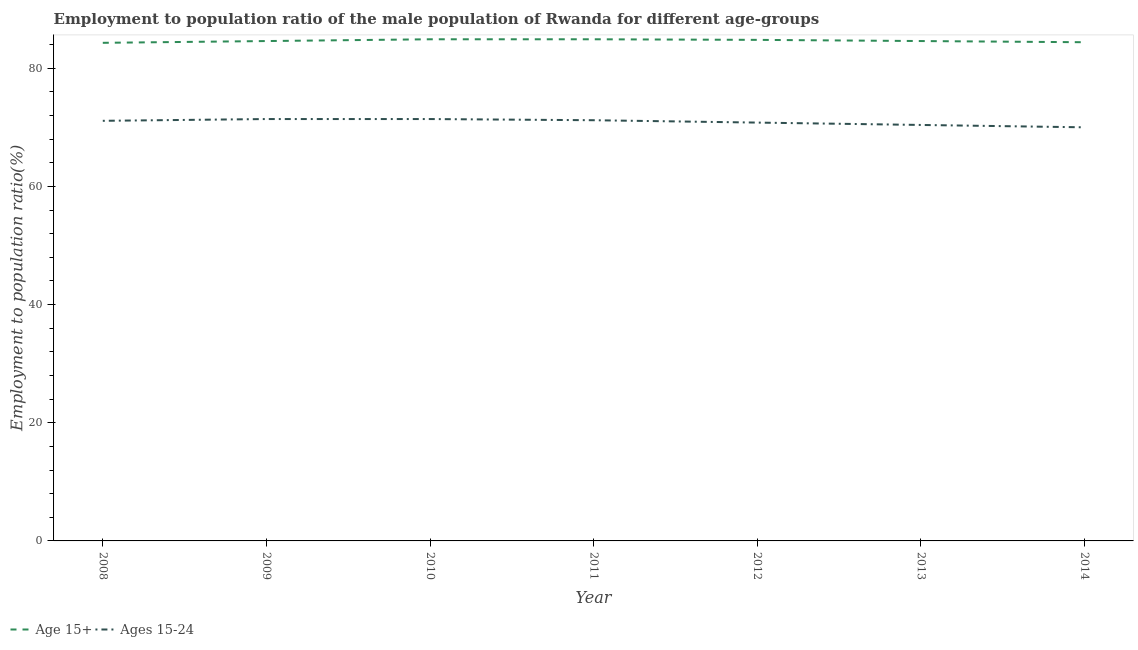Is the number of lines equal to the number of legend labels?
Provide a short and direct response. Yes. What is the employment to population ratio(age 15-24) in 2011?
Offer a terse response. 71.2. Across all years, what is the maximum employment to population ratio(age 15+)?
Make the answer very short. 84.9. Across all years, what is the minimum employment to population ratio(age 15-24)?
Ensure brevity in your answer.  70. What is the total employment to population ratio(age 15+) in the graph?
Your answer should be compact. 592.5. What is the difference between the employment to population ratio(age 15-24) in 2009 and that in 2012?
Provide a short and direct response. 0.6. What is the difference between the employment to population ratio(age 15-24) in 2011 and the employment to population ratio(age 15+) in 2010?
Provide a succinct answer. -13.7. What is the average employment to population ratio(age 15+) per year?
Offer a very short reply. 84.64. In the year 2010, what is the difference between the employment to population ratio(age 15-24) and employment to population ratio(age 15+)?
Offer a very short reply. -13.5. What is the ratio of the employment to population ratio(age 15-24) in 2010 to that in 2014?
Your answer should be very brief. 1.02. Is the difference between the employment to population ratio(age 15+) in 2012 and 2013 greater than the difference between the employment to population ratio(age 15-24) in 2012 and 2013?
Ensure brevity in your answer.  No. What is the difference between the highest and the lowest employment to population ratio(age 15-24)?
Your answer should be very brief. 1.4. Does the employment to population ratio(age 15+) monotonically increase over the years?
Give a very brief answer. No. Is the employment to population ratio(age 15+) strictly less than the employment to population ratio(age 15-24) over the years?
Provide a succinct answer. No. How many years are there in the graph?
Provide a succinct answer. 7. Does the graph contain any zero values?
Your answer should be very brief. No. Does the graph contain grids?
Your answer should be compact. No. Where does the legend appear in the graph?
Provide a succinct answer. Bottom left. What is the title of the graph?
Your response must be concise. Employment to population ratio of the male population of Rwanda for different age-groups. What is the label or title of the Y-axis?
Provide a succinct answer. Employment to population ratio(%). What is the Employment to population ratio(%) of Age 15+ in 2008?
Provide a succinct answer. 84.3. What is the Employment to population ratio(%) of Ages 15-24 in 2008?
Ensure brevity in your answer.  71.1. What is the Employment to population ratio(%) in Age 15+ in 2009?
Provide a short and direct response. 84.6. What is the Employment to population ratio(%) in Ages 15-24 in 2009?
Provide a short and direct response. 71.4. What is the Employment to population ratio(%) in Age 15+ in 2010?
Provide a short and direct response. 84.9. What is the Employment to population ratio(%) of Ages 15-24 in 2010?
Offer a very short reply. 71.4. What is the Employment to population ratio(%) in Age 15+ in 2011?
Ensure brevity in your answer.  84.9. What is the Employment to population ratio(%) in Ages 15-24 in 2011?
Give a very brief answer. 71.2. What is the Employment to population ratio(%) of Age 15+ in 2012?
Keep it short and to the point. 84.8. What is the Employment to population ratio(%) in Ages 15-24 in 2012?
Ensure brevity in your answer.  70.8. What is the Employment to population ratio(%) in Age 15+ in 2013?
Keep it short and to the point. 84.6. What is the Employment to population ratio(%) of Ages 15-24 in 2013?
Ensure brevity in your answer.  70.4. What is the Employment to population ratio(%) of Age 15+ in 2014?
Keep it short and to the point. 84.4. What is the Employment to population ratio(%) in Ages 15-24 in 2014?
Ensure brevity in your answer.  70. Across all years, what is the maximum Employment to population ratio(%) in Age 15+?
Your answer should be very brief. 84.9. Across all years, what is the maximum Employment to population ratio(%) in Ages 15-24?
Offer a very short reply. 71.4. Across all years, what is the minimum Employment to population ratio(%) of Age 15+?
Make the answer very short. 84.3. Across all years, what is the minimum Employment to population ratio(%) in Ages 15-24?
Give a very brief answer. 70. What is the total Employment to population ratio(%) in Age 15+ in the graph?
Offer a very short reply. 592.5. What is the total Employment to population ratio(%) in Ages 15-24 in the graph?
Keep it short and to the point. 496.3. What is the difference between the Employment to population ratio(%) in Age 15+ in 2008 and that in 2009?
Provide a short and direct response. -0.3. What is the difference between the Employment to population ratio(%) of Ages 15-24 in 2008 and that in 2009?
Provide a succinct answer. -0.3. What is the difference between the Employment to population ratio(%) of Ages 15-24 in 2008 and that in 2010?
Provide a succinct answer. -0.3. What is the difference between the Employment to population ratio(%) in Ages 15-24 in 2008 and that in 2011?
Ensure brevity in your answer.  -0.1. What is the difference between the Employment to population ratio(%) in Ages 15-24 in 2008 and that in 2012?
Your answer should be very brief. 0.3. What is the difference between the Employment to population ratio(%) of Age 15+ in 2008 and that in 2013?
Offer a terse response. -0.3. What is the difference between the Employment to population ratio(%) of Ages 15-24 in 2008 and that in 2013?
Give a very brief answer. 0.7. What is the difference between the Employment to population ratio(%) in Age 15+ in 2008 and that in 2014?
Provide a short and direct response. -0.1. What is the difference between the Employment to population ratio(%) in Ages 15-24 in 2009 and that in 2010?
Ensure brevity in your answer.  0. What is the difference between the Employment to population ratio(%) in Age 15+ in 2009 and that in 2011?
Give a very brief answer. -0.3. What is the difference between the Employment to population ratio(%) in Ages 15-24 in 2009 and that in 2011?
Provide a succinct answer. 0.2. What is the difference between the Employment to population ratio(%) in Age 15+ in 2009 and that in 2013?
Make the answer very short. 0. What is the difference between the Employment to population ratio(%) of Ages 15-24 in 2009 and that in 2013?
Your response must be concise. 1. What is the difference between the Employment to population ratio(%) of Ages 15-24 in 2009 and that in 2014?
Ensure brevity in your answer.  1.4. What is the difference between the Employment to population ratio(%) in Age 15+ in 2010 and that in 2011?
Offer a very short reply. 0. What is the difference between the Employment to population ratio(%) in Age 15+ in 2010 and that in 2012?
Your response must be concise. 0.1. What is the difference between the Employment to population ratio(%) of Age 15+ in 2010 and that in 2013?
Offer a very short reply. 0.3. What is the difference between the Employment to population ratio(%) of Ages 15-24 in 2010 and that in 2013?
Your response must be concise. 1. What is the difference between the Employment to population ratio(%) in Ages 15-24 in 2011 and that in 2012?
Your answer should be compact. 0.4. What is the difference between the Employment to population ratio(%) of Ages 15-24 in 2011 and that in 2013?
Your response must be concise. 0.8. What is the difference between the Employment to population ratio(%) of Age 15+ in 2011 and that in 2014?
Ensure brevity in your answer.  0.5. What is the difference between the Employment to population ratio(%) of Age 15+ in 2012 and that in 2013?
Offer a terse response. 0.2. What is the difference between the Employment to population ratio(%) of Age 15+ in 2013 and that in 2014?
Give a very brief answer. 0.2. What is the difference between the Employment to population ratio(%) of Age 15+ in 2008 and the Employment to population ratio(%) of Ages 15-24 in 2010?
Your answer should be compact. 12.9. What is the difference between the Employment to population ratio(%) of Age 15+ in 2008 and the Employment to population ratio(%) of Ages 15-24 in 2011?
Offer a terse response. 13.1. What is the difference between the Employment to population ratio(%) in Age 15+ in 2008 and the Employment to population ratio(%) in Ages 15-24 in 2012?
Provide a short and direct response. 13.5. What is the difference between the Employment to population ratio(%) in Age 15+ in 2008 and the Employment to population ratio(%) in Ages 15-24 in 2014?
Give a very brief answer. 14.3. What is the difference between the Employment to population ratio(%) in Age 15+ in 2009 and the Employment to population ratio(%) in Ages 15-24 in 2014?
Provide a short and direct response. 14.6. What is the difference between the Employment to population ratio(%) in Age 15+ in 2010 and the Employment to population ratio(%) in Ages 15-24 in 2013?
Your answer should be very brief. 14.5. What is the difference between the Employment to population ratio(%) of Age 15+ in 2011 and the Employment to population ratio(%) of Ages 15-24 in 2013?
Your answer should be compact. 14.5. What is the difference between the Employment to population ratio(%) of Age 15+ in 2012 and the Employment to population ratio(%) of Ages 15-24 in 2014?
Your response must be concise. 14.8. What is the difference between the Employment to population ratio(%) of Age 15+ in 2013 and the Employment to population ratio(%) of Ages 15-24 in 2014?
Offer a very short reply. 14.6. What is the average Employment to population ratio(%) of Age 15+ per year?
Offer a terse response. 84.64. What is the average Employment to population ratio(%) in Ages 15-24 per year?
Your response must be concise. 70.9. In the year 2008, what is the difference between the Employment to population ratio(%) of Age 15+ and Employment to population ratio(%) of Ages 15-24?
Provide a short and direct response. 13.2. In the year 2012, what is the difference between the Employment to population ratio(%) in Age 15+ and Employment to population ratio(%) in Ages 15-24?
Offer a very short reply. 14. What is the ratio of the Employment to population ratio(%) in Age 15+ in 2008 to that in 2010?
Offer a terse response. 0.99. What is the ratio of the Employment to population ratio(%) in Ages 15-24 in 2008 to that in 2011?
Ensure brevity in your answer.  1. What is the ratio of the Employment to population ratio(%) in Ages 15-24 in 2008 to that in 2012?
Your response must be concise. 1. What is the ratio of the Employment to population ratio(%) of Age 15+ in 2008 to that in 2013?
Ensure brevity in your answer.  1. What is the ratio of the Employment to population ratio(%) of Ages 15-24 in 2008 to that in 2013?
Make the answer very short. 1.01. What is the ratio of the Employment to population ratio(%) of Age 15+ in 2008 to that in 2014?
Offer a very short reply. 1. What is the ratio of the Employment to population ratio(%) of Ages 15-24 in 2008 to that in 2014?
Give a very brief answer. 1.02. What is the ratio of the Employment to population ratio(%) of Ages 15-24 in 2009 to that in 2010?
Provide a succinct answer. 1. What is the ratio of the Employment to population ratio(%) of Age 15+ in 2009 to that in 2011?
Make the answer very short. 1. What is the ratio of the Employment to population ratio(%) in Ages 15-24 in 2009 to that in 2012?
Provide a succinct answer. 1.01. What is the ratio of the Employment to population ratio(%) of Age 15+ in 2009 to that in 2013?
Your response must be concise. 1. What is the ratio of the Employment to population ratio(%) of Ages 15-24 in 2009 to that in 2013?
Ensure brevity in your answer.  1.01. What is the ratio of the Employment to population ratio(%) in Age 15+ in 2009 to that in 2014?
Provide a succinct answer. 1. What is the ratio of the Employment to population ratio(%) of Ages 15-24 in 2010 to that in 2011?
Provide a short and direct response. 1. What is the ratio of the Employment to population ratio(%) in Age 15+ in 2010 to that in 2012?
Offer a very short reply. 1. What is the ratio of the Employment to population ratio(%) in Ages 15-24 in 2010 to that in 2012?
Offer a very short reply. 1.01. What is the ratio of the Employment to population ratio(%) in Ages 15-24 in 2010 to that in 2013?
Your answer should be very brief. 1.01. What is the ratio of the Employment to population ratio(%) in Age 15+ in 2010 to that in 2014?
Your answer should be compact. 1.01. What is the ratio of the Employment to population ratio(%) in Ages 15-24 in 2011 to that in 2012?
Provide a succinct answer. 1.01. What is the ratio of the Employment to population ratio(%) in Ages 15-24 in 2011 to that in 2013?
Your answer should be compact. 1.01. What is the ratio of the Employment to population ratio(%) in Age 15+ in 2011 to that in 2014?
Provide a succinct answer. 1.01. What is the ratio of the Employment to population ratio(%) of Ages 15-24 in 2011 to that in 2014?
Make the answer very short. 1.02. What is the ratio of the Employment to population ratio(%) in Age 15+ in 2012 to that in 2013?
Make the answer very short. 1. What is the ratio of the Employment to population ratio(%) of Ages 15-24 in 2012 to that in 2013?
Give a very brief answer. 1.01. What is the ratio of the Employment to population ratio(%) of Age 15+ in 2012 to that in 2014?
Your response must be concise. 1. What is the ratio of the Employment to population ratio(%) of Ages 15-24 in 2012 to that in 2014?
Offer a terse response. 1.01. What is the ratio of the Employment to population ratio(%) of Ages 15-24 in 2013 to that in 2014?
Offer a terse response. 1.01. What is the difference between the highest and the second highest Employment to population ratio(%) in Age 15+?
Make the answer very short. 0. What is the difference between the highest and the second highest Employment to population ratio(%) of Ages 15-24?
Offer a terse response. 0. What is the difference between the highest and the lowest Employment to population ratio(%) of Age 15+?
Offer a terse response. 0.6. 